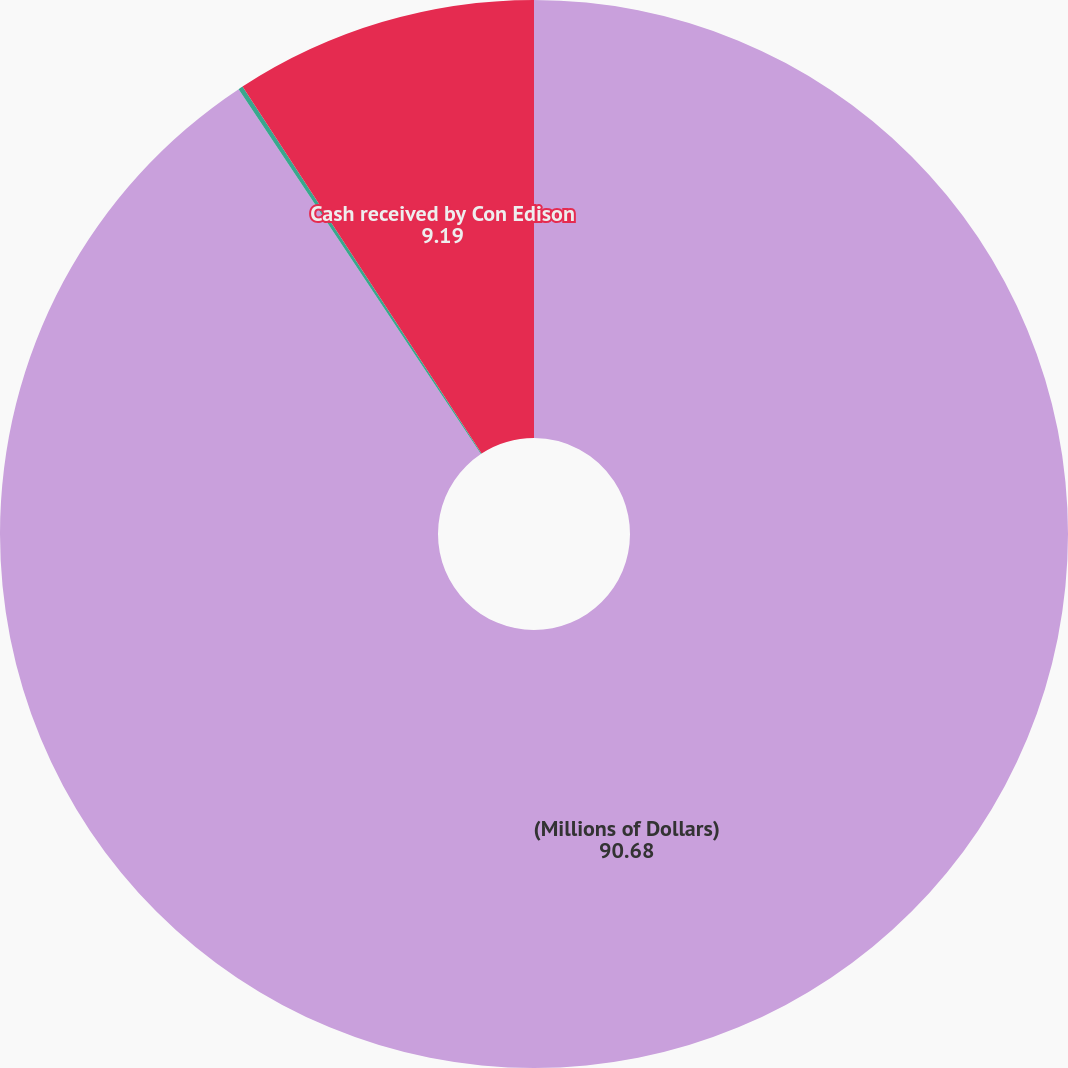<chart> <loc_0><loc_0><loc_500><loc_500><pie_chart><fcel>(Millions of Dollars)<fcel>Options exercised<fcel>Cash received by Con Edison<nl><fcel>90.68%<fcel>0.14%<fcel>9.19%<nl></chart> 